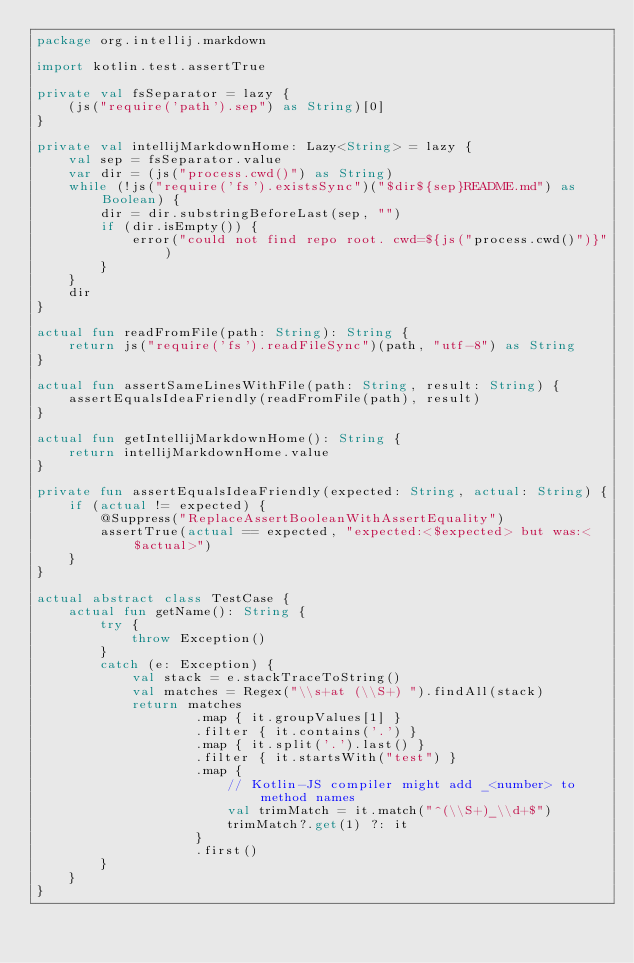Convert code to text. <code><loc_0><loc_0><loc_500><loc_500><_Kotlin_>package org.intellij.markdown

import kotlin.test.assertTrue

private val fsSeparator = lazy {
    (js("require('path').sep") as String)[0]
}

private val intellijMarkdownHome: Lazy<String> = lazy {
    val sep = fsSeparator.value
    var dir = (js("process.cwd()") as String)
    while (!js("require('fs').existsSync")("$dir${sep}README.md") as Boolean) {
        dir = dir.substringBeforeLast(sep, "")
        if (dir.isEmpty()) {
            error("could not find repo root. cwd=${js("process.cwd()")}")
        }
    }
    dir
}

actual fun readFromFile(path: String): String {
    return js("require('fs').readFileSync")(path, "utf-8") as String
}

actual fun assertSameLinesWithFile(path: String, result: String) {
    assertEqualsIdeaFriendly(readFromFile(path), result)
}

actual fun getIntellijMarkdownHome(): String {
    return intellijMarkdownHome.value
}

private fun assertEqualsIdeaFriendly(expected: String, actual: String) {
    if (actual != expected) {
        @Suppress("ReplaceAssertBooleanWithAssertEquality")
        assertTrue(actual == expected, "expected:<$expected> but was:<$actual>")
    }
}

actual abstract class TestCase {
    actual fun getName(): String {
        try {
            throw Exception()
        }
        catch (e: Exception) {
            val stack = e.stackTraceToString()
            val matches = Regex("\\s+at (\\S+) ").findAll(stack)
            return matches
                    .map { it.groupValues[1] }
                    .filter { it.contains('.') }
                    .map { it.split('.').last() }
                    .filter { it.startsWith("test") }
                    .map {
                        // Kotlin-JS compiler might add _<number> to method names
                        val trimMatch = it.match("^(\\S+)_\\d+$")
                        trimMatch?.get(1) ?: it
                    }
                    .first()
        }
    }
}</code> 